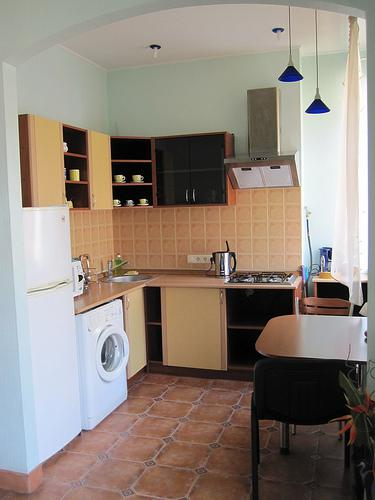Question: what room is this?
Choices:
A. Kitchen.
B. Bathroom.
C. Living Room.
D. Bedroom.
Answer with the letter. Answer: A Question: what is the color of the fridge?
Choices:
A. Silver.
B. Black.
C. Gray.
D. White.
Answer with the letter. Answer: D Question: where is the picture taken?
Choices:
A. Kitchen.
B. Living room.
C. Bathroom.
D. Dinning room.
Answer with the letter. Answer: A 